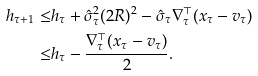Convert formula to latex. <formula><loc_0><loc_0><loc_500><loc_500>h _ { \tau + 1 } \leq & h _ { \tau } + \hat { \sigma } _ { \tau } ^ { 2 } ( 2 R ) ^ { 2 } - \hat { \sigma } _ { \tau } \nabla _ { \tau } ^ { \top } ( x _ { \tau } - v _ { \tau } ) \\ \leq & h _ { \tau } - \frac { \nabla _ { \tau } ^ { \top } ( x _ { \tau } - v _ { \tau } ) } { 2 } .</formula> 